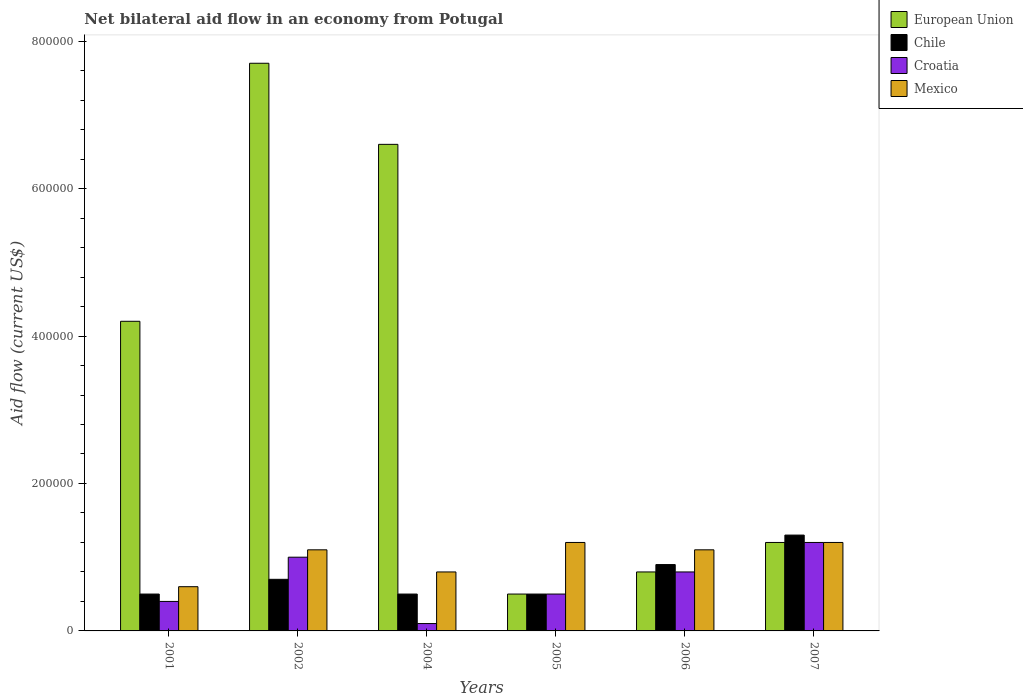How many different coloured bars are there?
Offer a terse response. 4. How many groups of bars are there?
Keep it short and to the point. 6. Are the number of bars on each tick of the X-axis equal?
Keep it short and to the point. Yes. How many bars are there on the 4th tick from the left?
Offer a terse response. 4. How many bars are there on the 3rd tick from the right?
Make the answer very short. 4. What is the net bilateral aid flow in Croatia in 2001?
Offer a very short reply. 4.00e+04. Across all years, what is the maximum net bilateral aid flow in European Union?
Provide a short and direct response. 7.70e+05. Across all years, what is the minimum net bilateral aid flow in Mexico?
Ensure brevity in your answer.  6.00e+04. In which year was the net bilateral aid flow in Croatia minimum?
Offer a terse response. 2004. What is the total net bilateral aid flow in European Union in the graph?
Ensure brevity in your answer.  2.10e+06. What is the difference between the net bilateral aid flow in Mexico in 2005 and that in 2006?
Provide a succinct answer. 10000. What is the difference between the net bilateral aid flow in European Union in 2007 and the net bilateral aid flow in Croatia in 2005?
Ensure brevity in your answer.  7.00e+04. What is the average net bilateral aid flow in Chile per year?
Make the answer very short. 7.33e+04. In the year 2007, what is the difference between the net bilateral aid flow in European Union and net bilateral aid flow in Croatia?
Keep it short and to the point. 0. What is the ratio of the net bilateral aid flow in Mexico in 2005 to that in 2006?
Offer a very short reply. 1.09. What is the difference between the highest and the lowest net bilateral aid flow in European Union?
Provide a short and direct response. 7.20e+05. Is it the case that in every year, the sum of the net bilateral aid flow in Chile and net bilateral aid flow in Croatia is greater than the sum of net bilateral aid flow in Mexico and net bilateral aid flow in European Union?
Your answer should be very brief. No. What is the difference between two consecutive major ticks on the Y-axis?
Offer a very short reply. 2.00e+05. Does the graph contain grids?
Make the answer very short. No. How are the legend labels stacked?
Your response must be concise. Vertical. What is the title of the graph?
Provide a short and direct response. Net bilateral aid flow in an economy from Potugal. Does "Estonia" appear as one of the legend labels in the graph?
Provide a short and direct response. No. What is the label or title of the Y-axis?
Make the answer very short. Aid flow (current US$). What is the Aid flow (current US$) in European Union in 2001?
Your answer should be compact. 4.20e+05. What is the Aid flow (current US$) of Chile in 2001?
Ensure brevity in your answer.  5.00e+04. What is the Aid flow (current US$) in Mexico in 2001?
Ensure brevity in your answer.  6.00e+04. What is the Aid flow (current US$) of European Union in 2002?
Your answer should be very brief. 7.70e+05. What is the Aid flow (current US$) in European Union in 2004?
Your answer should be very brief. 6.60e+05. What is the Aid flow (current US$) in Croatia in 2004?
Give a very brief answer. 10000. What is the Aid flow (current US$) of Croatia in 2005?
Your answer should be very brief. 5.00e+04. What is the Aid flow (current US$) of European Union in 2006?
Offer a very short reply. 8.00e+04. What is the Aid flow (current US$) of Chile in 2006?
Your answer should be very brief. 9.00e+04. What is the Aid flow (current US$) of Croatia in 2006?
Make the answer very short. 8.00e+04. What is the Aid flow (current US$) of Mexico in 2006?
Offer a terse response. 1.10e+05. What is the Aid flow (current US$) of European Union in 2007?
Offer a very short reply. 1.20e+05. What is the Aid flow (current US$) of Croatia in 2007?
Make the answer very short. 1.20e+05. What is the Aid flow (current US$) in Mexico in 2007?
Your answer should be very brief. 1.20e+05. Across all years, what is the maximum Aid flow (current US$) of European Union?
Your answer should be very brief. 7.70e+05. Across all years, what is the maximum Aid flow (current US$) of Mexico?
Offer a very short reply. 1.20e+05. Across all years, what is the minimum Aid flow (current US$) in European Union?
Offer a very short reply. 5.00e+04. What is the total Aid flow (current US$) in European Union in the graph?
Your answer should be compact. 2.10e+06. What is the total Aid flow (current US$) of Croatia in the graph?
Offer a very short reply. 4.00e+05. What is the total Aid flow (current US$) in Mexico in the graph?
Your answer should be compact. 6.00e+05. What is the difference between the Aid flow (current US$) in European Union in 2001 and that in 2002?
Your response must be concise. -3.50e+05. What is the difference between the Aid flow (current US$) in Chile in 2001 and that in 2002?
Offer a terse response. -2.00e+04. What is the difference between the Aid flow (current US$) of Mexico in 2001 and that in 2002?
Offer a very short reply. -5.00e+04. What is the difference between the Aid flow (current US$) in European Union in 2001 and that in 2004?
Offer a terse response. -2.40e+05. What is the difference between the Aid flow (current US$) of Chile in 2001 and that in 2004?
Ensure brevity in your answer.  0. What is the difference between the Aid flow (current US$) of Croatia in 2001 and that in 2004?
Your answer should be compact. 3.00e+04. What is the difference between the Aid flow (current US$) of Mexico in 2001 and that in 2004?
Provide a succinct answer. -2.00e+04. What is the difference between the Aid flow (current US$) in European Union in 2001 and that in 2005?
Provide a short and direct response. 3.70e+05. What is the difference between the Aid flow (current US$) in Mexico in 2001 and that in 2005?
Your response must be concise. -6.00e+04. What is the difference between the Aid flow (current US$) of Chile in 2001 and that in 2006?
Give a very brief answer. -4.00e+04. What is the difference between the Aid flow (current US$) of European Union in 2001 and that in 2007?
Provide a short and direct response. 3.00e+05. What is the difference between the Aid flow (current US$) of Chile in 2001 and that in 2007?
Keep it short and to the point. -8.00e+04. What is the difference between the Aid flow (current US$) of European Union in 2002 and that in 2004?
Make the answer very short. 1.10e+05. What is the difference between the Aid flow (current US$) in European Union in 2002 and that in 2005?
Offer a very short reply. 7.20e+05. What is the difference between the Aid flow (current US$) of European Union in 2002 and that in 2006?
Your answer should be compact. 6.90e+05. What is the difference between the Aid flow (current US$) of Mexico in 2002 and that in 2006?
Provide a short and direct response. 0. What is the difference between the Aid flow (current US$) in European Union in 2002 and that in 2007?
Give a very brief answer. 6.50e+05. What is the difference between the Aid flow (current US$) of Croatia in 2002 and that in 2007?
Offer a very short reply. -2.00e+04. What is the difference between the Aid flow (current US$) in European Union in 2004 and that in 2006?
Keep it short and to the point. 5.80e+05. What is the difference between the Aid flow (current US$) of Croatia in 2004 and that in 2006?
Make the answer very short. -7.00e+04. What is the difference between the Aid flow (current US$) in Mexico in 2004 and that in 2006?
Give a very brief answer. -3.00e+04. What is the difference between the Aid flow (current US$) of European Union in 2004 and that in 2007?
Provide a succinct answer. 5.40e+05. What is the difference between the Aid flow (current US$) of Chile in 2004 and that in 2007?
Your answer should be compact. -8.00e+04. What is the difference between the Aid flow (current US$) of Croatia in 2004 and that in 2007?
Ensure brevity in your answer.  -1.10e+05. What is the difference between the Aid flow (current US$) of Mexico in 2004 and that in 2007?
Provide a short and direct response. -4.00e+04. What is the difference between the Aid flow (current US$) in European Union in 2005 and that in 2006?
Keep it short and to the point. -3.00e+04. What is the difference between the Aid flow (current US$) in Croatia in 2005 and that in 2006?
Give a very brief answer. -3.00e+04. What is the difference between the Aid flow (current US$) of Mexico in 2005 and that in 2006?
Your response must be concise. 10000. What is the difference between the Aid flow (current US$) of European Union in 2006 and that in 2007?
Keep it short and to the point. -4.00e+04. What is the difference between the Aid flow (current US$) in Chile in 2006 and that in 2007?
Your response must be concise. -4.00e+04. What is the difference between the Aid flow (current US$) of Mexico in 2006 and that in 2007?
Your response must be concise. -10000. What is the difference between the Aid flow (current US$) of European Union in 2001 and the Aid flow (current US$) of Chile in 2002?
Offer a very short reply. 3.50e+05. What is the difference between the Aid flow (current US$) in Chile in 2001 and the Aid flow (current US$) in Mexico in 2002?
Offer a very short reply. -6.00e+04. What is the difference between the Aid flow (current US$) of European Union in 2001 and the Aid flow (current US$) of Chile in 2004?
Provide a short and direct response. 3.70e+05. What is the difference between the Aid flow (current US$) in European Union in 2001 and the Aid flow (current US$) in Croatia in 2004?
Give a very brief answer. 4.10e+05. What is the difference between the Aid flow (current US$) of Croatia in 2001 and the Aid flow (current US$) of Mexico in 2004?
Give a very brief answer. -4.00e+04. What is the difference between the Aid flow (current US$) of European Union in 2001 and the Aid flow (current US$) of Croatia in 2005?
Your answer should be very brief. 3.70e+05. What is the difference between the Aid flow (current US$) in European Union in 2001 and the Aid flow (current US$) in Mexico in 2005?
Provide a short and direct response. 3.00e+05. What is the difference between the Aid flow (current US$) in Chile in 2001 and the Aid flow (current US$) in Croatia in 2005?
Your answer should be compact. 0. What is the difference between the Aid flow (current US$) in Croatia in 2001 and the Aid flow (current US$) in Mexico in 2005?
Your answer should be very brief. -8.00e+04. What is the difference between the Aid flow (current US$) in European Union in 2001 and the Aid flow (current US$) in Chile in 2006?
Your response must be concise. 3.30e+05. What is the difference between the Aid flow (current US$) of Chile in 2001 and the Aid flow (current US$) of Mexico in 2006?
Provide a succinct answer. -6.00e+04. What is the difference between the Aid flow (current US$) in Croatia in 2001 and the Aid flow (current US$) in Mexico in 2006?
Offer a very short reply. -7.00e+04. What is the difference between the Aid flow (current US$) of European Union in 2001 and the Aid flow (current US$) of Mexico in 2007?
Make the answer very short. 3.00e+05. What is the difference between the Aid flow (current US$) of European Union in 2002 and the Aid flow (current US$) of Chile in 2004?
Keep it short and to the point. 7.20e+05. What is the difference between the Aid flow (current US$) of European Union in 2002 and the Aid flow (current US$) of Croatia in 2004?
Your answer should be compact. 7.60e+05. What is the difference between the Aid flow (current US$) of European Union in 2002 and the Aid flow (current US$) of Mexico in 2004?
Ensure brevity in your answer.  6.90e+05. What is the difference between the Aid flow (current US$) of Chile in 2002 and the Aid flow (current US$) of Croatia in 2004?
Offer a terse response. 6.00e+04. What is the difference between the Aid flow (current US$) in European Union in 2002 and the Aid flow (current US$) in Chile in 2005?
Provide a short and direct response. 7.20e+05. What is the difference between the Aid flow (current US$) of European Union in 2002 and the Aid flow (current US$) of Croatia in 2005?
Keep it short and to the point. 7.20e+05. What is the difference between the Aid flow (current US$) in European Union in 2002 and the Aid flow (current US$) in Mexico in 2005?
Keep it short and to the point. 6.50e+05. What is the difference between the Aid flow (current US$) in Chile in 2002 and the Aid flow (current US$) in Croatia in 2005?
Provide a short and direct response. 2.00e+04. What is the difference between the Aid flow (current US$) of Chile in 2002 and the Aid flow (current US$) of Mexico in 2005?
Make the answer very short. -5.00e+04. What is the difference between the Aid flow (current US$) of Croatia in 2002 and the Aid flow (current US$) of Mexico in 2005?
Offer a very short reply. -2.00e+04. What is the difference between the Aid flow (current US$) of European Union in 2002 and the Aid flow (current US$) of Chile in 2006?
Ensure brevity in your answer.  6.80e+05. What is the difference between the Aid flow (current US$) in European Union in 2002 and the Aid flow (current US$) in Croatia in 2006?
Provide a short and direct response. 6.90e+05. What is the difference between the Aid flow (current US$) in Chile in 2002 and the Aid flow (current US$) in Croatia in 2006?
Provide a succinct answer. -10000. What is the difference between the Aid flow (current US$) of Chile in 2002 and the Aid flow (current US$) of Mexico in 2006?
Your answer should be very brief. -4.00e+04. What is the difference between the Aid flow (current US$) in European Union in 2002 and the Aid flow (current US$) in Chile in 2007?
Provide a succinct answer. 6.40e+05. What is the difference between the Aid flow (current US$) in European Union in 2002 and the Aid flow (current US$) in Croatia in 2007?
Ensure brevity in your answer.  6.50e+05. What is the difference between the Aid flow (current US$) of European Union in 2002 and the Aid flow (current US$) of Mexico in 2007?
Ensure brevity in your answer.  6.50e+05. What is the difference between the Aid flow (current US$) of Chile in 2002 and the Aid flow (current US$) of Mexico in 2007?
Provide a succinct answer. -5.00e+04. What is the difference between the Aid flow (current US$) of Croatia in 2002 and the Aid flow (current US$) of Mexico in 2007?
Provide a succinct answer. -2.00e+04. What is the difference between the Aid flow (current US$) of European Union in 2004 and the Aid flow (current US$) of Chile in 2005?
Offer a terse response. 6.10e+05. What is the difference between the Aid flow (current US$) of European Union in 2004 and the Aid flow (current US$) of Croatia in 2005?
Your answer should be compact. 6.10e+05. What is the difference between the Aid flow (current US$) in European Union in 2004 and the Aid flow (current US$) in Mexico in 2005?
Give a very brief answer. 5.40e+05. What is the difference between the Aid flow (current US$) of Chile in 2004 and the Aid flow (current US$) of Croatia in 2005?
Keep it short and to the point. 0. What is the difference between the Aid flow (current US$) of Croatia in 2004 and the Aid flow (current US$) of Mexico in 2005?
Give a very brief answer. -1.10e+05. What is the difference between the Aid flow (current US$) in European Union in 2004 and the Aid flow (current US$) in Chile in 2006?
Ensure brevity in your answer.  5.70e+05. What is the difference between the Aid flow (current US$) in European Union in 2004 and the Aid flow (current US$) in Croatia in 2006?
Provide a succinct answer. 5.80e+05. What is the difference between the Aid flow (current US$) of European Union in 2004 and the Aid flow (current US$) of Mexico in 2006?
Your response must be concise. 5.50e+05. What is the difference between the Aid flow (current US$) in European Union in 2004 and the Aid flow (current US$) in Chile in 2007?
Keep it short and to the point. 5.30e+05. What is the difference between the Aid flow (current US$) of European Union in 2004 and the Aid flow (current US$) of Croatia in 2007?
Your answer should be compact. 5.40e+05. What is the difference between the Aid flow (current US$) in European Union in 2004 and the Aid flow (current US$) in Mexico in 2007?
Give a very brief answer. 5.40e+05. What is the difference between the Aid flow (current US$) of Chile in 2004 and the Aid flow (current US$) of Mexico in 2007?
Provide a short and direct response. -7.00e+04. What is the difference between the Aid flow (current US$) in European Union in 2005 and the Aid flow (current US$) in Mexico in 2006?
Your response must be concise. -6.00e+04. What is the difference between the Aid flow (current US$) in Chile in 2005 and the Aid flow (current US$) in Croatia in 2006?
Provide a short and direct response. -3.00e+04. What is the difference between the Aid flow (current US$) of Chile in 2005 and the Aid flow (current US$) of Mexico in 2006?
Provide a short and direct response. -6.00e+04. What is the difference between the Aid flow (current US$) in Croatia in 2005 and the Aid flow (current US$) in Mexico in 2006?
Give a very brief answer. -6.00e+04. What is the difference between the Aid flow (current US$) of European Union in 2005 and the Aid flow (current US$) of Chile in 2007?
Ensure brevity in your answer.  -8.00e+04. What is the difference between the Aid flow (current US$) of European Union in 2005 and the Aid flow (current US$) of Mexico in 2007?
Provide a short and direct response. -7.00e+04. What is the difference between the Aid flow (current US$) in Chile in 2005 and the Aid flow (current US$) in Mexico in 2007?
Give a very brief answer. -7.00e+04. What is the difference between the Aid flow (current US$) of Chile in 2006 and the Aid flow (current US$) of Croatia in 2007?
Keep it short and to the point. -3.00e+04. What is the difference between the Aid flow (current US$) of Chile in 2006 and the Aid flow (current US$) of Mexico in 2007?
Keep it short and to the point. -3.00e+04. What is the average Aid flow (current US$) of Chile per year?
Provide a short and direct response. 7.33e+04. What is the average Aid flow (current US$) in Croatia per year?
Ensure brevity in your answer.  6.67e+04. In the year 2001, what is the difference between the Aid flow (current US$) in European Union and Aid flow (current US$) in Croatia?
Offer a terse response. 3.80e+05. In the year 2002, what is the difference between the Aid flow (current US$) of European Union and Aid flow (current US$) of Croatia?
Provide a succinct answer. 6.70e+05. In the year 2002, what is the difference between the Aid flow (current US$) of European Union and Aid flow (current US$) of Mexico?
Keep it short and to the point. 6.60e+05. In the year 2002, what is the difference between the Aid flow (current US$) in Chile and Aid flow (current US$) in Mexico?
Make the answer very short. -4.00e+04. In the year 2004, what is the difference between the Aid flow (current US$) in European Union and Aid flow (current US$) in Croatia?
Your answer should be compact. 6.50e+05. In the year 2004, what is the difference between the Aid flow (current US$) of European Union and Aid flow (current US$) of Mexico?
Give a very brief answer. 5.80e+05. In the year 2004, what is the difference between the Aid flow (current US$) of Chile and Aid flow (current US$) of Mexico?
Your response must be concise. -3.00e+04. In the year 2004, what is the difference between the Aid flow (current US$) of Croatia and Aid flow (current US$) of Mexico?
Your answer should be compact. -7.00e+04. In the year 2005, what is the difference between the Aid flow (current US$) in European Union and Aid flow (current US$) in Mexico?
Provide a succinct answer. -7.00e+04. In the year 2005, what is the difference between the Aid flow (current US$) in Chile and Aid flow (current US$) in Mexico?
Give a very brief answer. -7.00e+04. In the year 2006, what is the difference between the Aid flow (current US$) in European Union and Aid flow (current US$) in Chile?
Your answer should be very brief. -10000. In the year 2006, what is the difference between the Aid flow (current US$) in Chile and Aid flow (current US$) in Croatia?
Provide a succinct answer. 10000. In the year 2007, what is the difference between the Aid flow (current US$) in European Union and Aid flow (current US$) in Croatia?
Make the answer very short. 0. What is the ratio of the Aid flow (current US$) in European Union in 2001 to that in 2002?
Ensure brevity in your answer.  0.55. What is the ratio of the Aid flow (current US$) of Mexico in 2001 to that in 2002?
Provide a succinct answer. 0.55. What is the ratio of the Aid flow (current US$) of European Union in 2001 to that in 2004?
Make the answer very short. 0.64. What is the ratio of the Aid flow (current US$) of Chile in 2001 to that in 2005?
Give a very brief answer. 1. What is the ratio of the Aid flow (current US$) of European Union in 2001 to that in 2006?
Offer a very short reply. 5.25. What is the ratio of the Aid flow (current US$) in Chile in 2001 to that in 2006?
Keep it short and to the point. 0.56. What is the ratio of the Aid flow (current US$) of Mexico in 2001 to that in 2006?
Give a very brief answer. 0.55. What is the ratio of the Aid flow (current US$) in European Union in 2001 to that in 2007?
Your answer should be compact. 3.5. What is the ratio of the Aid flow (current US$) in Chile in 2001 to that in 2007?
Your response must be concise. 0.38. What is the ratio of the Aid flow (current US$) of Mexico in 2001 to that in 2007?
Offer a very short reply. 0.5. What is the ratio of the Aid flow (current US$) of Croatia in 2002 to that in 2004?
Ensure brevity in your answer.  10. What is the ratio of the Aid flow (current US$) of Mexico in 2002 to that in 2004?
Keep it short and to the point. 1.38. What is the ratio of the Aid flow (current US$) of European Union in 2002 to that in 2005?
Provide a succinct answer. 15.4. What is the ratio of the Aid flow (current US$) of Chile in 2002 to that in 2005?
Ensure brevity in your answer.  1.4. What is the ratio of the Aid flow (current US$) of Mexico in 2002 to that in 2005?
Your answer should be very brief. 0.92. What is the ratio of the Aid flow (current US$) of European Union in 2002 to that in 2006?
Your answer should be very brief. 9.62. What is the ratio of the Aid flow (current US$) in Chile in 2002 to that in 2006?
Your answer should be very brief. 0.78. What is the ratio of the Aid flow (current US$) of Croatia in 2002 to that in 2006?
Keep it short and to the point. 1.25. What is the ratio of the Aid flow (current US$) of Mexico in 2002 to that in 2006?
Offer a terse response. 1. What is the ratio of the Aid flow (current US$) of European Union in 2002 to that in 2007?
Your answer should be very brief. 6.42. What is the ratio of the Aid flow (current US$) of Chile in 2002 to that in 2007?
Keep it short and to the point. 0.54. What is the ratio of the Aid flow (current US$) of Mexico in 2002 to that in 2007?
Ensure brevity in your answer.  0.92. What is the ratio of the Aid flow (current US$) of European Union in 2004 to that in 2006?
Make the answer very short. 8.25. What is the ratio of the Aid flow (current US$) in Chile in 2004 to that in 2006?
Your answer should be compact. 0.56. What is the ratio of the Aid flow (current US$) of Mexico in 2004 to that in 2006?
Provide a short and direct response. 0.73. What is the ratio of the Aid flow (current US$) of Chile in 2004 to that in 2007?
Make the answer very short. 0.38. What is the ratio of the Aid flow (current US$) in Croatia in 2004 to that in 2007?
Your answer should be compact. 0.08. What is the ratio of the Aid flow (current US$) in Mexico in 2004 to that in 2007?
Give a very brief answer. 0.67. What is the ratio of the Aid flow (current US$) of European Union in 2005 to that in 2006?
Your answer should be compact. 0.62. What is the ratio of the Aid flow (current US$) in Chile in 2005 to that in 2006?
Give a very brief answer. 0.56. What is the ratio of the Aid flow (current US$) of Croatia in 2005 to that in 2006?
Keep it short and to the point. 0.62. What is the ratio of the Aid flow (current US$) in European Union in 2005 to that in 2007?
Keep it short and to the point. 0.42. What is the ratio of the Aid flow (current US$) of Chile in 2005 to that in 2007?
Offer a very short reply. 0.38. What is the ratio of the Aid flow (current US$) in Croatia in 2005 to that in 2007?
Provide a succinct answer. 0.42. What is the ratio of the Aid flow (current US$) in European Union in 2006 to that in 2007?
Offer a terse response. 0.67. What is the ratio of the Aid flow (current US$) in Chile in 2006 to that in 2007?
Offer a very short reply. 0.69. What is the ratio of the Aid flow (current US$) of Croatia in 2006 to that in 2007?
Provide a succinct answer. 0.67. What is the difference between the highest and the second highest Aid flow (current US$) of Chile?
Keep it short and to the point. 4.00e+04. What is the difference between the highest and the second highest Aid flow (current US$) of Mexico?
Your answer should be very brief. 0. What is the difference between the highest and the lowest Aid flow (current US$) of European Union?
Provide a short and direct response. 7.20e+05. 